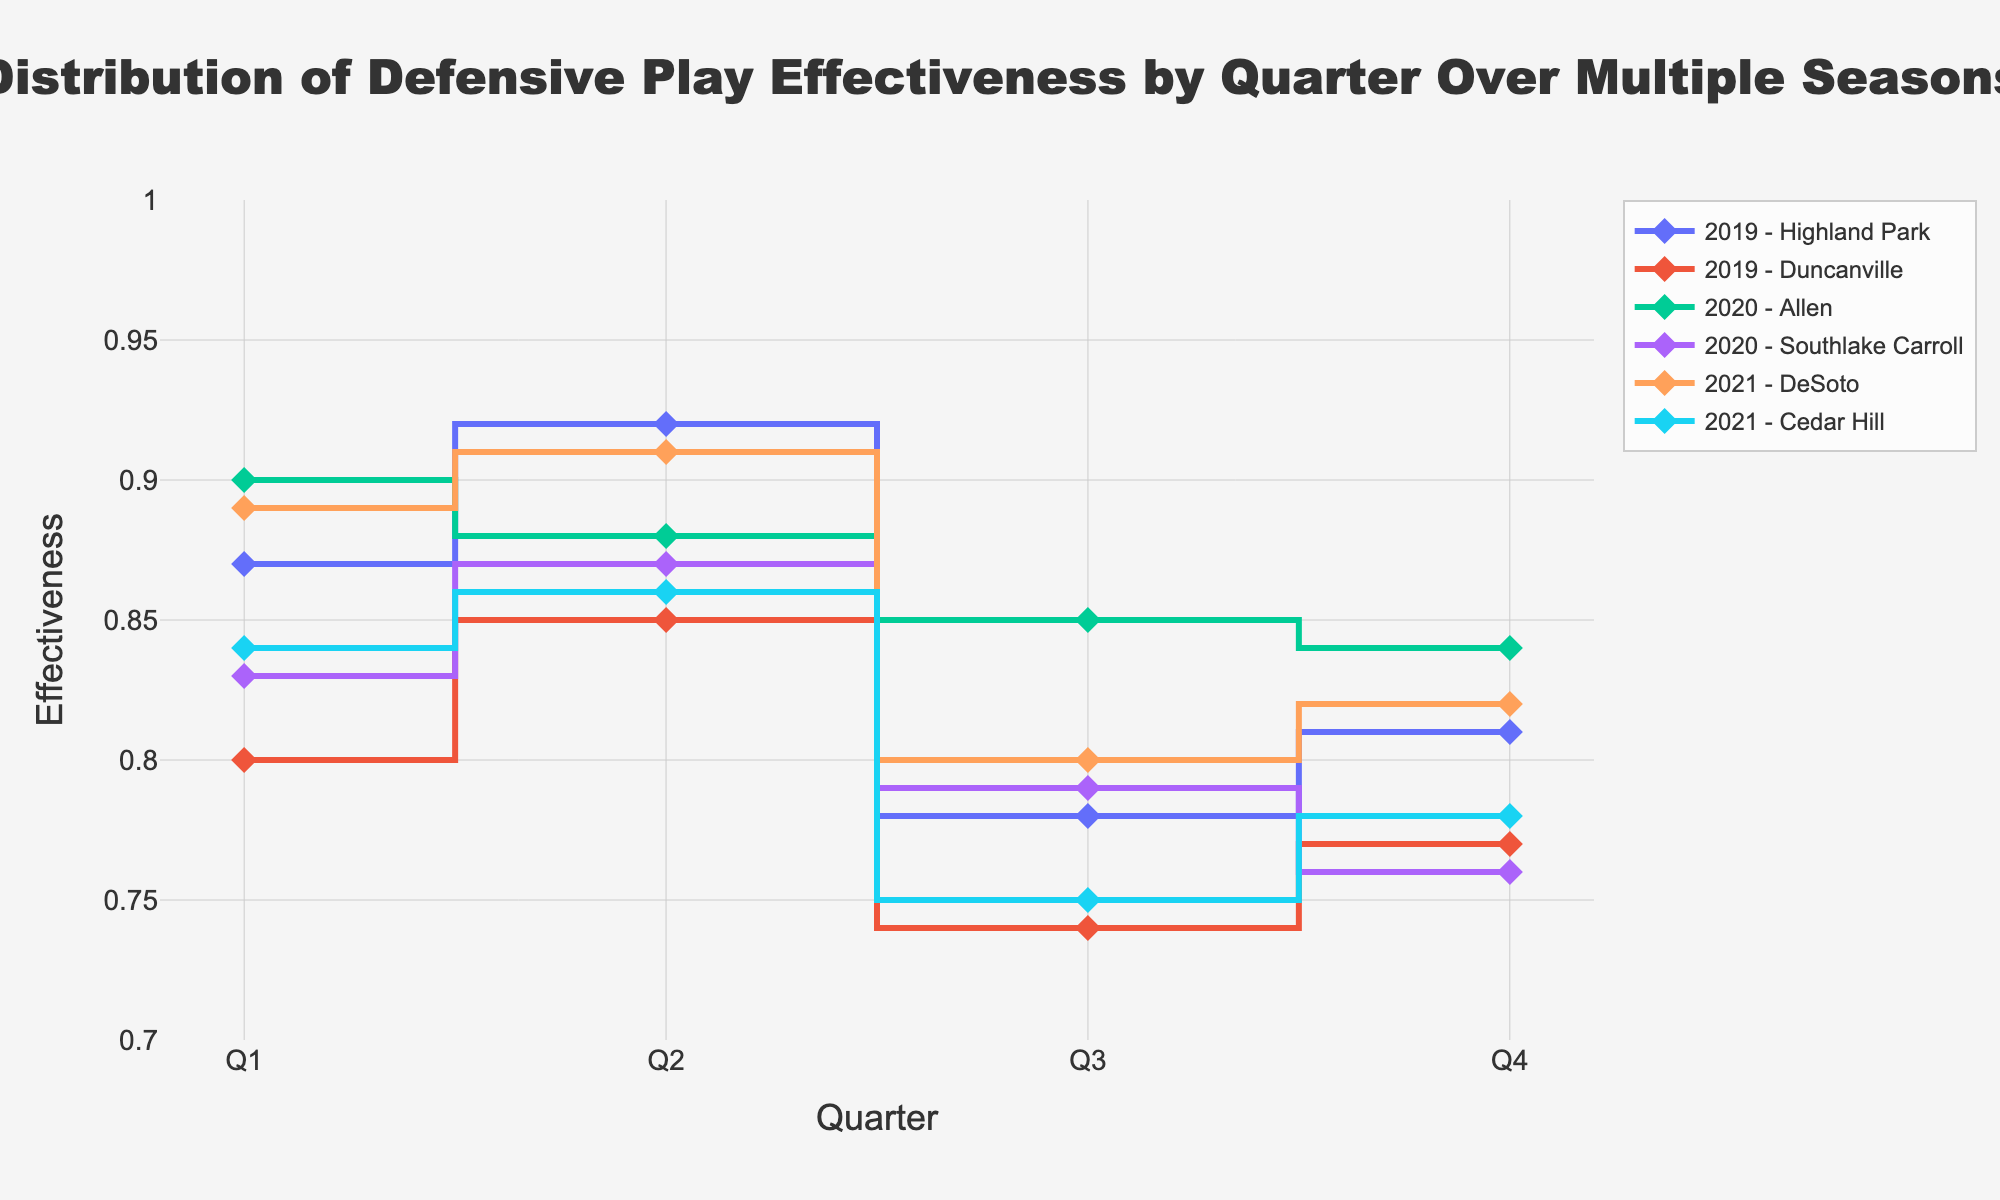What's the highest defensive play effectiveness in the first quarter for any season? The figure shows the effectiveness by quarter for different seasons and opponents. By examining all values in the first quarter, the highest value is 0.90 for Allen in 2020.
Answer: 0.90 For which opponent in 2019 does the effectiveness drop the most between any two consecutive quarters? To determine this, we need to check the differences in effectiveness between any two quarters for each opponent in 2019. For Duncanville, the drop from Q2 (0.85) to Q3 (0.74) is the largest, which is 0.11. For Highland Park, the largest drop is from Q2 (0.92) to Q3 (0.78), which is 0.14. Therefore, Highland Park has the largest drop.
Answer: Highland Park Which opponent has the most consistent defensive effectiveness throughout a season? Consistency is observed by checking how close the values are across the quarters for an opponent. For DeSoto in 2021, the values are 0.89, 0.91, 0.80, and 0.82, showing less variation compared to others.
Answer: DeSoto What's the average defensive effectiveness in the fourth quarter across all seasons and opponents? To find the average, we add up all values for the fourth quarter: (0.81 + 0.77 + 0.84 + 0.76 + 0.82 + 0.78) = 4.78, then divide by the number of entries, which is 6. Therefore, the average is 4.78 / 6 = 0.80.
Answer: 0.80 Which season has the overall highest defensive effectiveness? To determine this, we calculate the average effectiveness for each season. Summing up and averaging for each season:
2019: (0.87 + 0.92 + 0.78 + 0.81 + 0.80 + 0.85 + 0.74 + 0.77) / 8 = 0.79
2020: (0.90 + 0.88 + 0.85 + 0.84 + 0.83 + 0.87 + 0.79 + 0.76) / 8 = 0.84
2021: (0.89 + 0.91 + 0.80 + 0.82 + 0.84 + 0.86 + 0.75 + 0.78) / 8 = 0.83
Hence, 2020 has the highest overall effectiveness.
Answer: 2020 